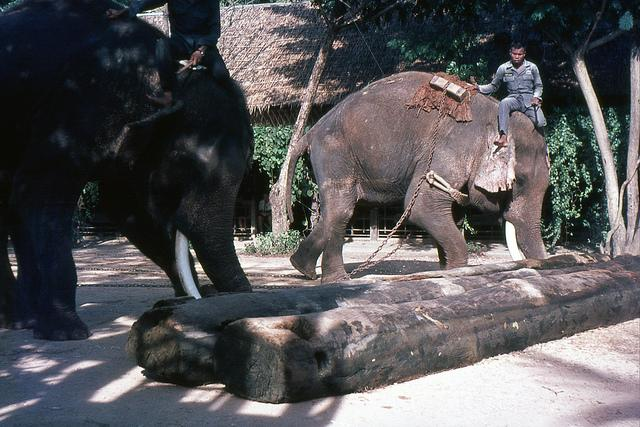What power will be used to move logs here? Please explain your reasoning. elephant. The elephant is pushing the logs with his trunk. 